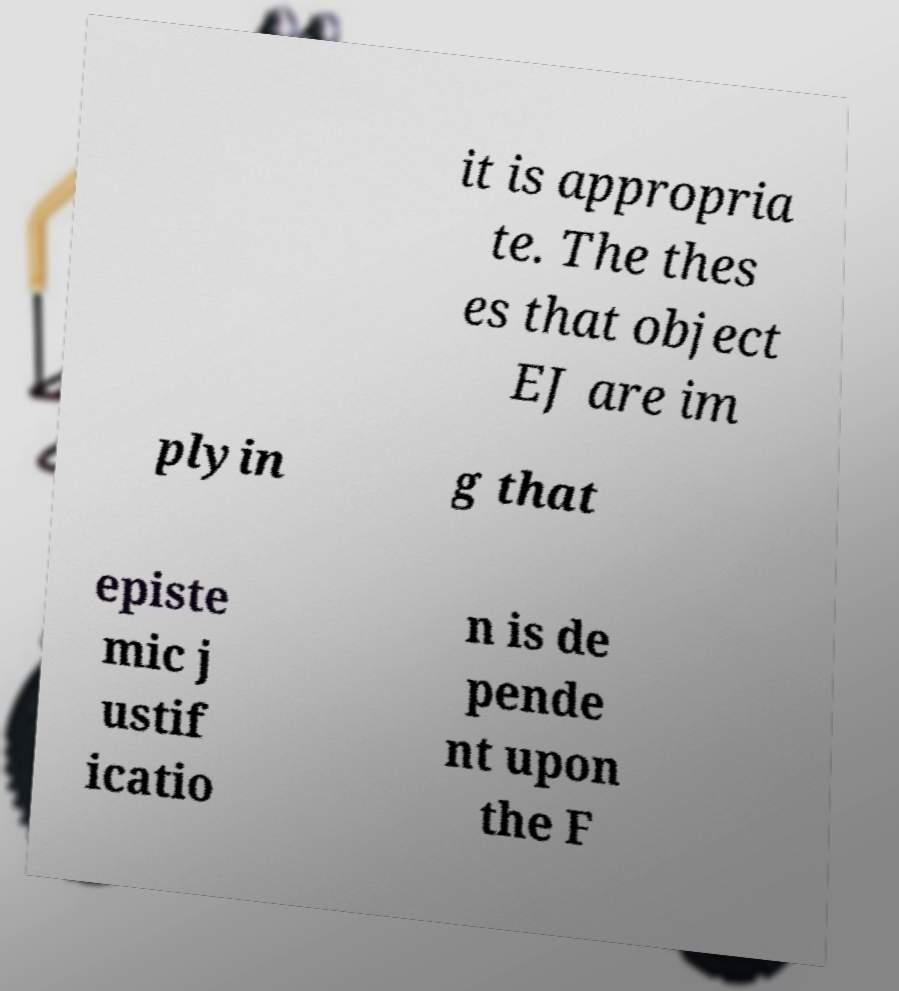Can you read and provide the text displayed in the image?This photo seems to have some interesting text. Can you extract and type it out for me? it is appropria te. The thes es that object EJ are im plyin g that episte mic j ustif icatio n is de pende nt upon the F 